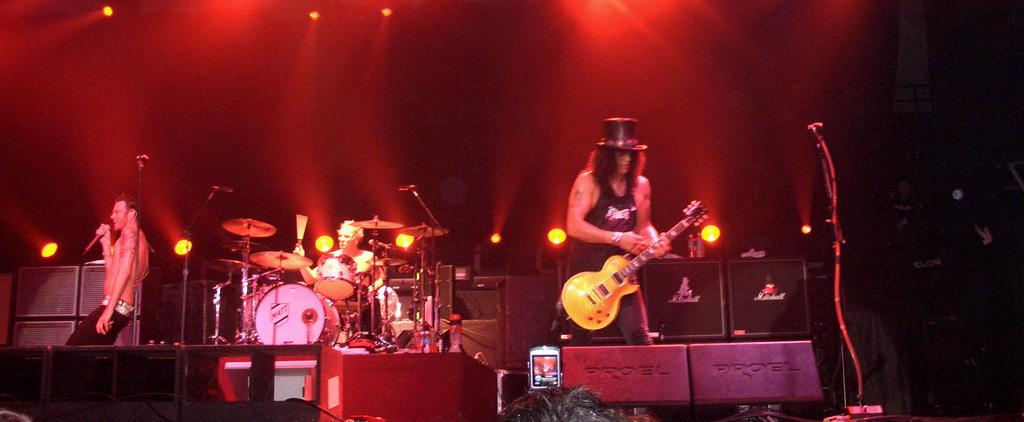What are the three people on the dais doing? One man is singing with the help of a microphone, one man is playing the guitar, and one man is playing drums. What is the man with the microphone using to amplify his voice? The man with the microphone is using a microphone to amplify his voice. What is the role of the audience in the image? The audience is watching the performance of the three people on the dais. What type of tin is being used to cook the stew in the image? There is no tin or stew present in the image; it features three people performing on a dais. What is the price of the drum set being used in the performance? The image does not provide information about the price of the drum set or any other equipment being used in the performance. 